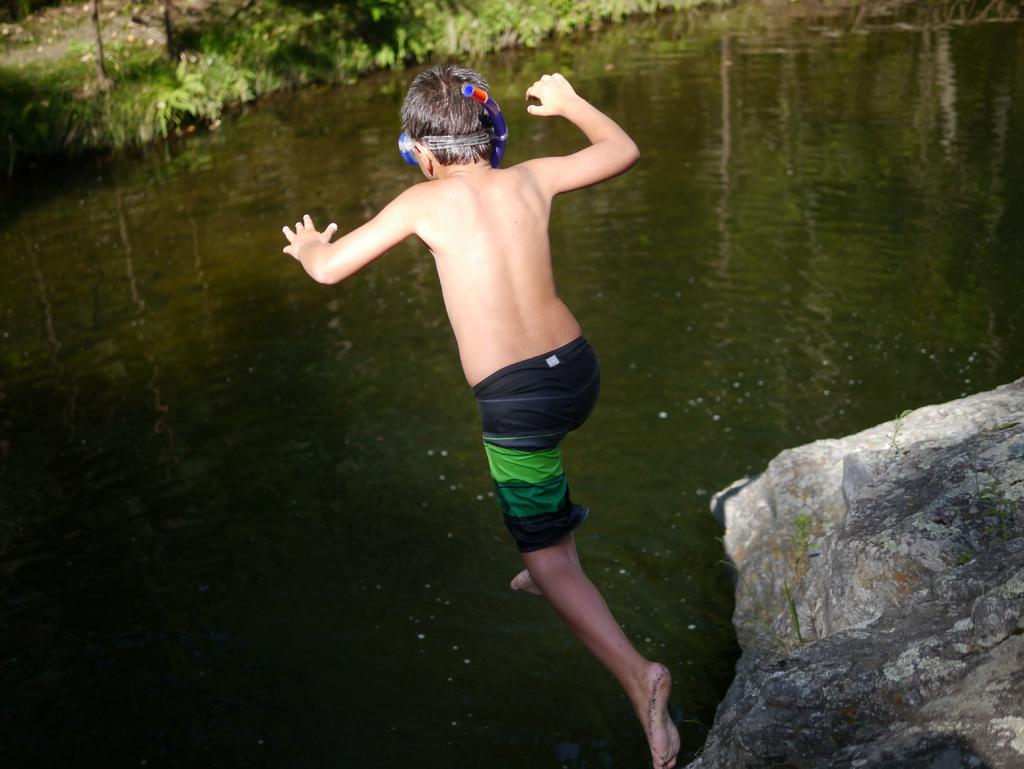What is the person in the image doing? The person is in the air in the image. What is the person wearing? The person is wearing a black and green color boxer. What can be seen to the right of the person? There is a rock to the right of the person. What is visible in the image besides the person and the rock? Water is visible in the image, and trees are present in the background. What type of pest is crawling on the person's boxer in the image? There is no pest visible on the person's boxer in the image. How does the person answer the question in the image? There is no question present in the image for the person to answer. 